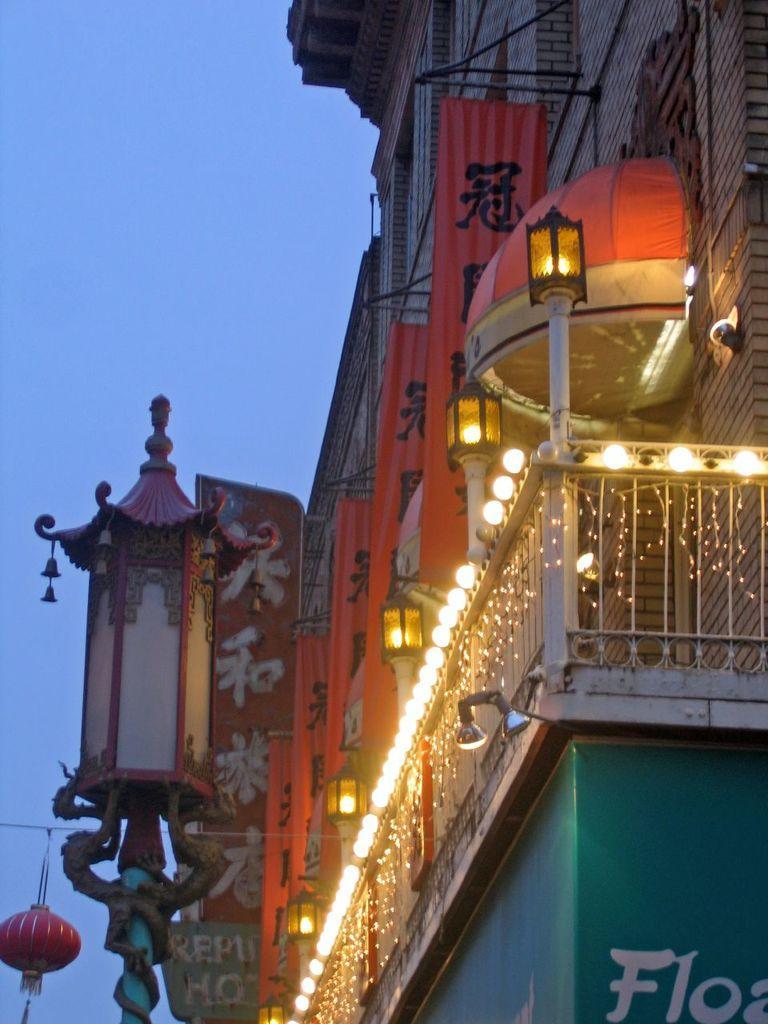Could you give a brief overview of what you see in this image? In the picture we can see a part of the building with railing to it and decorative lights to it and a pole with a lamp to the building and beside the building we can see a sky. 